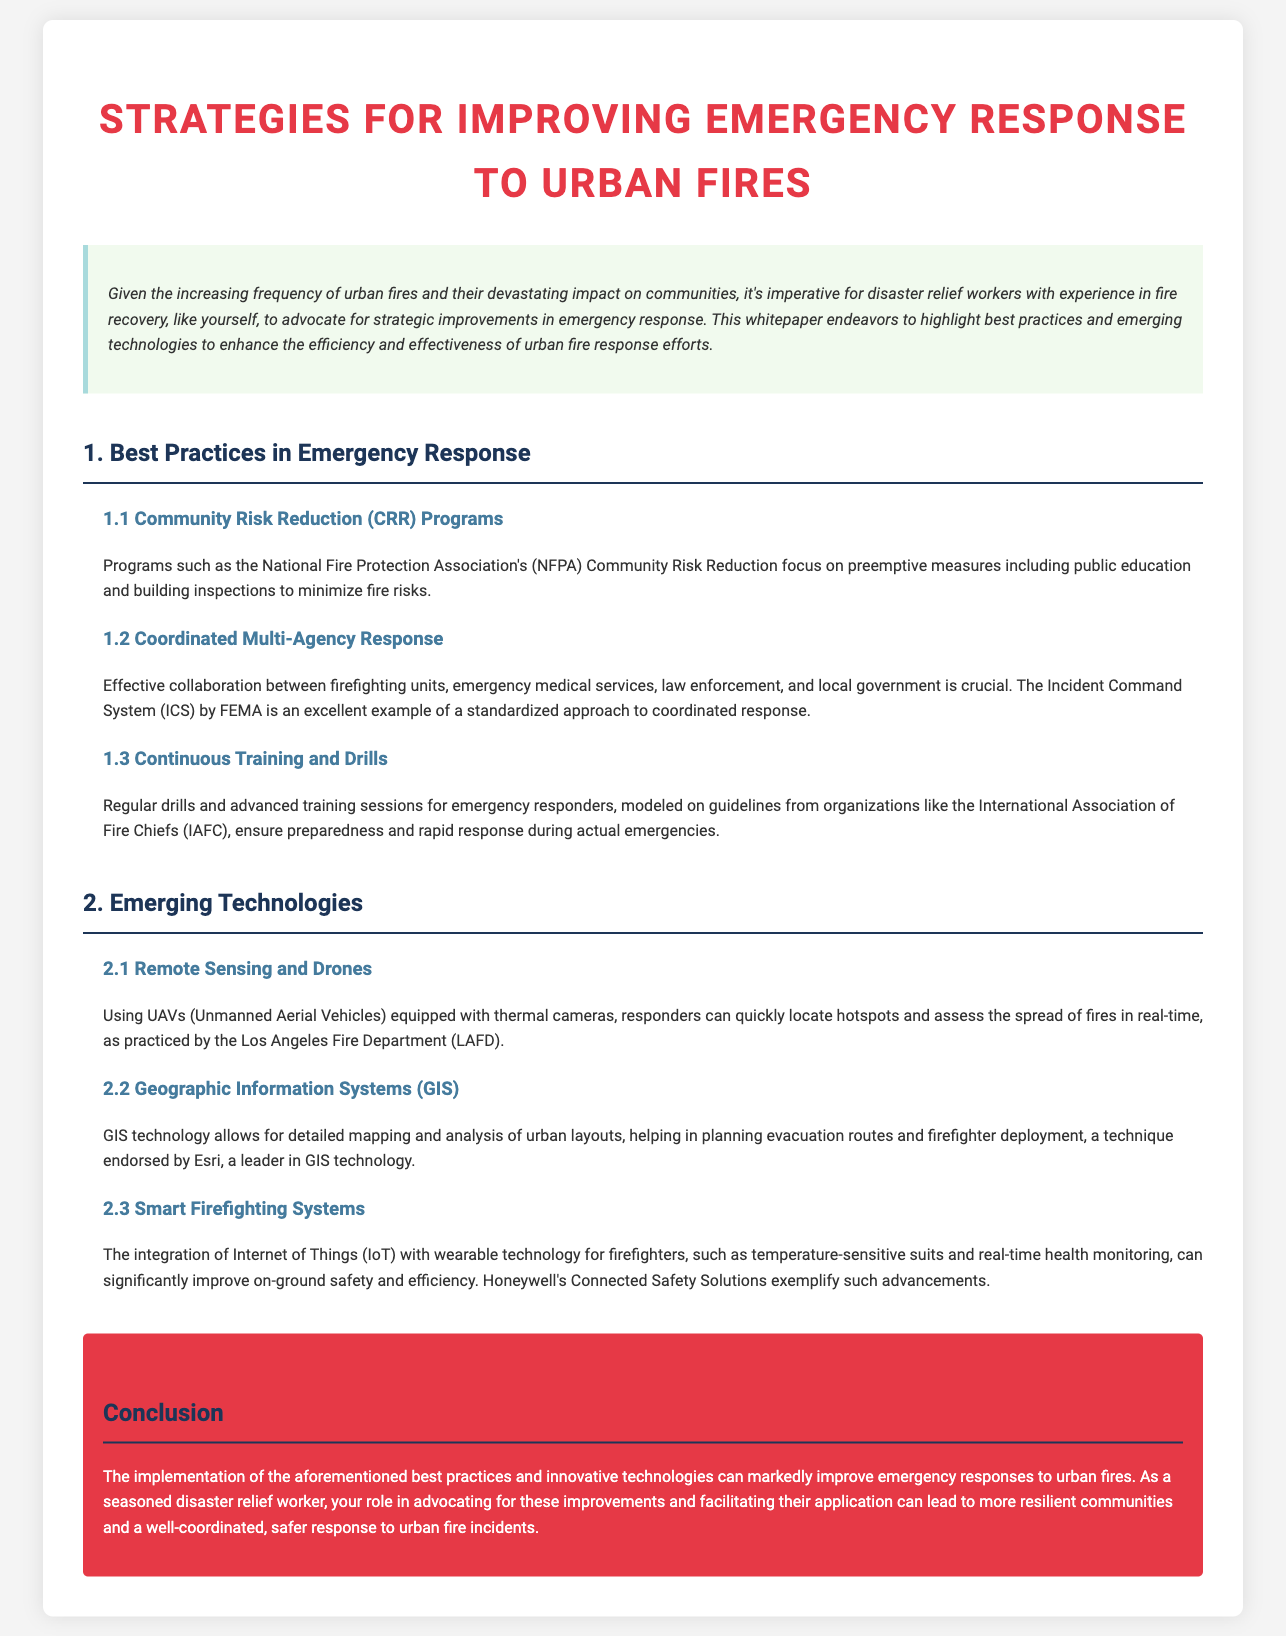what is the title of the whitepaper? The title of the whitepaper is prominently displayed at the top of the document.
Answer: Strategies for Improving Emergency Response to Urban Fires what is a recommended program for Community Risk Reduction? The document mentions the National Fire Protection Association's program as a key example for CRR.
Answer: NFPA Community Risk Reduction what technology is used for remote sensing in fire response? The document specifies the usage of UAVs equipped with thermal cameras for this purpose.
Answer: UAVs which system does FEMA use for coordinated response? The document refers to a specific system used for coordinated emergency response by FEMA.
Answer: Incident Command System what type of wearable technology is mentioned for firefighters? The document states that temperature-sensitive suits are an example of wearable technology for firefighters.
Answer: temperature-sensitive suits which leader in GIS technology is mentioned in the document? The whitepaper identifies a specific company recognized for its GIS technology support.
Answer: Esri what is one key benefit of continuous training for responders? The text highlights the importance of preparedness as a result of ongoing training for emergency response teams.
Answer: preparedness what is the primary color of the conclusion section? The conclusion section has a distinct color that differentiates it from other sections of the document.
Answer: red 